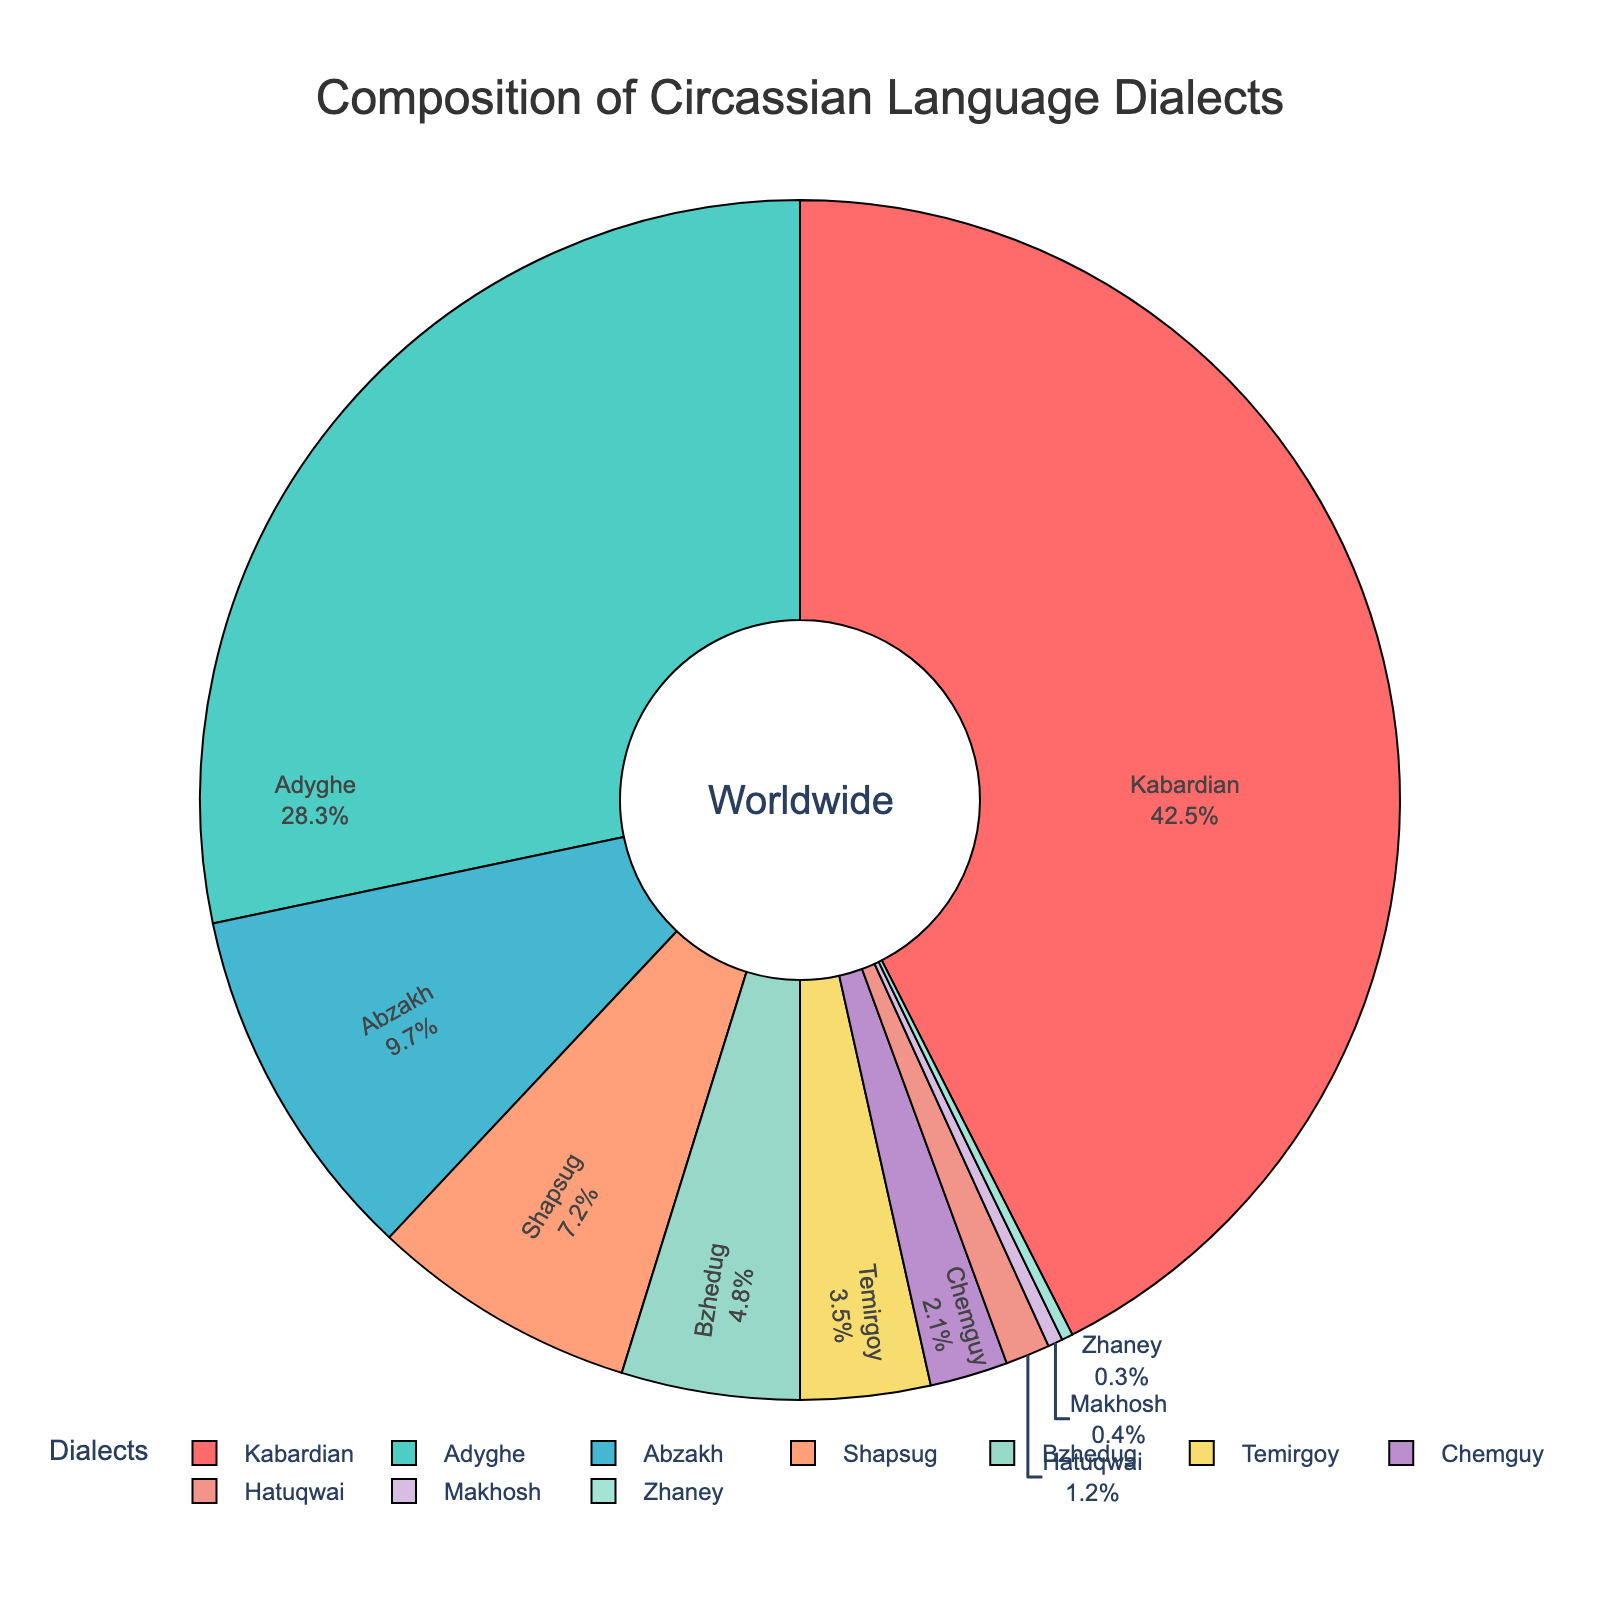Which Circassian dialect is spoken the most worldwide? Looking at the pie chart, we can see that the largest segment corresponds to the Kabardian dialect with 42.5%.
Answer: Kabardian How much more percentage does Kabardian have compared to Adyghe? From the pie chart, Kabardian has 42.5% and Adyghe has 28.3%. Subtracting these values gives 42.5% - 28.3% = 14.2%.
Answer: 14.2% Which dialect is the smallest and what percentage does it represent? The smallest segment in the pie chart is labeled Zhaney, which represents 0.3%.
Answer: Zhaney, 0.3% What is the combined percentage of the Shapsug and Abzakh dialects? The pie chart shows Shapsug at 7.2% and Abzakh at 9.7%. Summing these values gives 7.2% + 9.7% = 16.9%.
Answer: 16.9% Are there more people speaking Temirgoy or Bzhedug dialect? By looking at the pie chart, we can see that Bzhedug represents 4.8% and Temirgoy represents 3.5%. Therefore, more people speak the Bzhedug dialect.
Answer: Bzhedug What percentage of Circassians worldwide speak either Chemguy or Hatuqwai dialects? According to the pie chart, Chemguy represents 2.1% and Hatuqwai represents 1.2%. Adding these values gives 2.1% + 1.2% = 3.3%.
Answer: 3.3% Which two dialects together make up half of the Circassian language speakers worldwide? Adding up the largest portions in descending order, Kabardian is 42.5% and Adyghe is 28.3%. Their sum is 42.5% + 28.3% = 70.8%, which exceeds 50%. However, Kabardian alone is not enough, and Kabardian plus Adyghe exceeds the needed half. So the two dialects are Kabardian and Adyghe.
Answer: Kabardian and Adyghe 